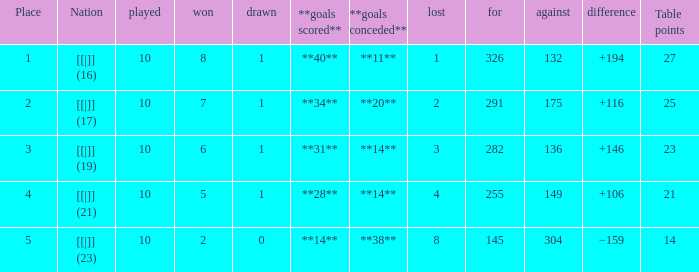 How many table points are listed for the deficit is +194?  1.0. 